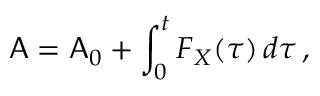Convert formula to latex. <formula><loc_0><loc_0><loc_500><loc_500>A = A _ { 0 } + \int _ { 0 } ^ { t } F _ { X } ( \tau ) \, d \tau \, ,</formula> 